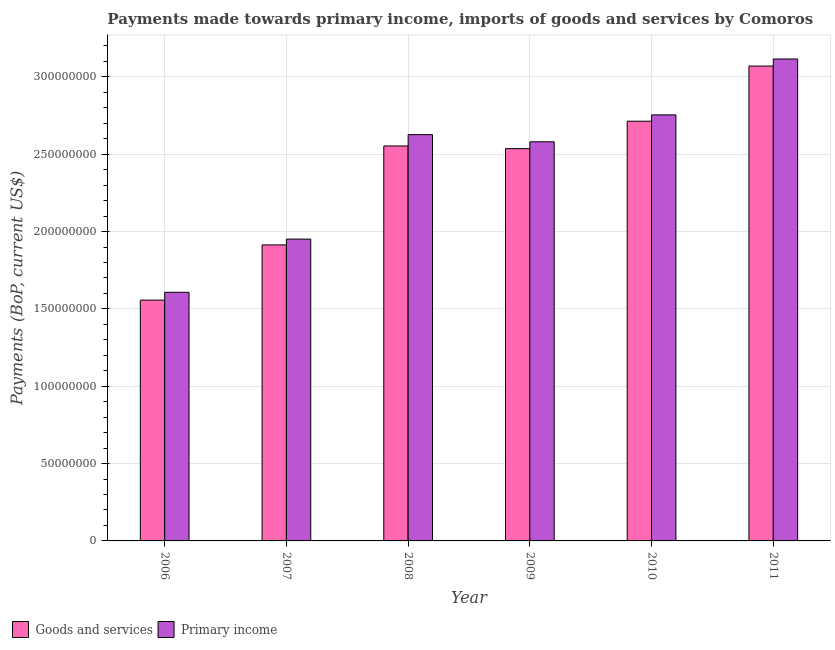How many different coloured bars are there?
Your response must be concise. 2. Are the number of bars per tick equal to the number of legend labels?
Offer a terse response. Yes. How many bars are there on the 5th tick from the left?
Offer a very short reply. 2. What is the payments made towards primary income in 2011?
Your answer should be very brief. 3.12e+08. Across all years, what is the maximum payments made towards goods and services?
Ensure brevity in your answer.  3.07e+08. Across all years, what is the minimum payments made towards goods and services?
Offer a terse response. 1.56e+08. What is the total payments made towards goods and services in the graph?
Offer a very short reply. 1.43e+09. What is the difference between the payments made towards goods and services in 2007 and that in 2010?
Provide a short and direct response. -8.00e+07. What is the difference between the payments made towards primary income in 2009 and the payments made towards goods and services in 2007?
Offer a terse response. 6.29e+07. What is the average payments made towards primary income per year?
Ensure brevity in your answer.  2.44e+08. In the year 2006, what is the difference between the payments made towards goods and services and payments made towards primary income?
Provide a short and direct response. 0. In how many years, is the payments made towards primary income greater than 100000000 US$?
Keep it short and to the point. 6. What is the ratio of the payments made towards goods and services in 2009 to that in 2010?
Give a very brief answer. 0.93. What is the difference between the highest and the second highest payments made towards goods and services?
Provide a short and direct response. 3.57e+07. What is the difference between the highest and the lowest payments made towards primary income?
Keep it short and to the point. 1.51e+08. In how many years, is the payments made towards goods and services greater than the average payments made towards goods and services taken over all years?
Ensure brevity in your answer.  4. What does the 2nd bar from the left in 2007 represents?
Ensure brevity in your answer.  Primary income. What does the 2nd bar from the right in 2011 represents?
Your response must be concise. Goods and services. What is the difference between two consecutive major ticks on the Y-axis?
Ensure brevity in your answer.  5.00e+07. Are the values on the major ticks of Y-axis written in scientific E-notation?
Offer a terse response. No. Does the graph contain any zero values?
Your answer should be very brief. No. Where does the legend appear in the graph?
Offer a very short reply. Bottom left. How are the legend labels stacked?
Provide a succinct answer. Horizontal. What is the title of the graph?
Give a very brief answer. Payments made towards primary income, imports of goods and services by Comoros. What is the label or title of the X-axis?
Offer a terse response. Year. What is the label or title of the Y-axis?
Give a very brief answer. Payments (BoP, current US$). What is the Payments (BoP, current US$) in Goods and services in 2006?
Offer a terse response. 1.56e+08. What is the Payments (BoP, current US$) in Primary income in 2006?
Provide a short and direct response. 1.61e+08. What is the Payments (BoP, current US$) of Goods and services in 2007?
Ensure brevity in your answer.  1.91e+08. What is the Payments (BoP, current US$) of Primary income in 2007?
Your answer should be very brief. 1.95e+08. What is the Payments (BoP, current US$) of Goods and services in 2008?
Ensure brevity in your answer.  2.55e+08. What is the Payments (BoP, current US$) in Primary income in 2008?
Offer a very short reply. 2.63e+08. What is the Payments (BoP, current US$) in Goods and services in 2009?
Offer a very short reply. 2.54e+08. What is the Payments (BoP, current US$) of Primary income in 2009?
Provide a short and direct response. 2.58e+08. What is the Payments (BoP, current US$) in Goods and services in 2010?
Ensure brevity in your answer.  2.71e+08. What is the Payments (BoP, current US$) of Primary income in 2010?
Offer a terse response. 2.75e+08. What is the Payments (BoP, current US$) of Goods and services in 2011?
Make the answer very short. 3.07e+08. What is the Payments (BoP, current US$) in Primary income in 2011?
Provide a short and direct response. 3.12e+08. Across all years, what is the maximum Payments (BoP, current US$) in Goods and services?
Your answer should be very brief. 3.07e+08. Across all years, what is the maximum Payments (BoP, current US$) in Primary income?
Your answer should be very brief. 3.12e+08. Across all years, what is the minimum Payments (BoP, current US$) in Goods and services?
Provide a short and direct response. 1.56e+08. Across all years, what is the minimum Payments (BoP, current US$) of Primary income?
Give a very brief answer. 1.61e+08. What is the total Payments (BoP, current US$) in Goods and services in the graph?
Give a very brief answer. 1.43e+09. What is the total Payments (BoP, current US$) of Primary income in the graph?
Your answer should be compact. 1.46e+09. What is the difference between the Payments (BoP, current US$) of Goods and services in 2006 and that in 2007?
Provide a short and direct response. -3.57e+07. What is the difference between the Payments (BoP, current US$) in Primary income in 2006 and that in 2007?
Make the answer very short. -3.44e+07. What is the difference between the Payments (BoP, current US$) in Goods and services in 2006 and that in 2008?
Offer a very short reply. -9.97e+07. What is the difference between the Payments (BoP, current US$) in Primary income in 2006 and that in 2008?
Ensure brevity in your answer.  -1.02e+08. What is the difference between the Payments (BoP, current US$) in Goods and services in 2006 and that in 2009?
Your response must be concise. -9.79e+07. What is the difference between the Payments (BoP, current US$) of Primary income in 2006 and that in 2009?
Make the answer very short. -9.73e+07. What is the difference between the Payments (BoP, current US$) of Goods and services in 2006 and that in 2010?
Your response must be concise. -1.16e+08. What is the difference between the Payments (BoP, current US$) in Primary income in 2006 and that in 2010?
Ensure brevity in your answer.  -1.15e+08. What is the difference between the Payments (BoP, current US$) of Goods and services in 2006 and that in 2011?
Provide a short and direct response. -1.51e+08. What is the difference between the Payments (BoP, current US$) of Primary income in 2006 and that in 2011?
Ensure brevity in your answer.  -1.51e+08. What is the difference between the Payments (BoP, current US$) in Goods and services in 2007 and that in 2008?
Provide a succinct answer. -6.40e+07. What is the difference between the Payments (BoP, current US$) of Primary income in 2007 and that in 2008?
Provide a short and direct response. -6.75e+07. What is the difference between the Payments (BoP, current US$) of Goods and services in 2007 and that in 2009?
Keep it short and to the point. -6.22e+07. What is the difference between the Payments (BoP, current US$) of Primary income in 2007 and that in 2009?
Ensure brevity in your answer.  -6.29e+07. What is the difference between the Payments (BoP, current US$) of Goods and services in 2007 and that in 2010?
Offer a very short reply. -8.00e+07. What is the difference between the Payments (BoP, current US$) in Primary income in 2007 and that in 2010?
Give a very brief answer. -8.03e+07. What is the difference between the Payments (BoP, current US$) of Goods and services in 2007 and that in 2011?
Provide a succinct answer. -1.16e+08. What is the difference between the Payments (BoP, current US$) of Primary income in 2007 and that in 2011?
Offer a very short reply. -1.16e+08. What is the difference between the Payments (BoP, current US$) in Goods and services in 2008 and that in 2009?
Offer a terse response. 1.74e+06. What is the difference between the Payments (BoP, current US$) in Primary income in 2008 and that in 2009?
Give a very brief answer. 4.63e+06. What is the difference between the Payments (BoP, current US$) in Goods and services in 2008 and that in 2010?
Ensure brevity in your answer.  -1.60e+07. What is the difference between the Payments (BoP, current US$) in Primary income in 2008 and that in 2010?
Offer a terse response. -1.28e+07. What is the difference between the Payments (BoP, current US$) in Goods and services in 2008 and that in 2011?
Your answer should be very brief. -5.17e+07. What is the difference between the Payments (BoP, current US$) of Primary income in 2008 and that in 2011?
Make the answer very short. -4.89e+07. What is the difference between the Payments (BoP, current US$) of Goods and services in 2009 and that in 2010?
Your answer should be compact. -1.77e+07. What is the difference between the Payments (BoP, current US$) in Primary income in 2009 and that in 2010?
Ensure brevity in your answer.  -1.74e+07. What is the difference between the Payments (BoP, current US$) in Goods and services in 2009 and that in 2011?
Your answer should be very brief. -5.34e+07. What is the difference between the Payments (BoP, current US$) in Primary income in 2009 and that in 2011?
Ensure brevity in your answer.  -5.35e+07. What is the difference between the Payments (BoP, current US$) in Goods and services in 2010 and that in 2011?
Provide a short and direct response. -3.57e+07. What is the difference between the Payments (BoP, current US$) in Primary income in 2010 and that in 2011?
Provide a succinct answer. -3.61e+07. What is the difference between the Payments (BoP, current US$) in Goods and services in 2006 and the Payments (BoP, current US$) in Primary income in 2007?
Ensure brevity in your answer.  -3.94e+07. What is the difference between the Payments (BoP, current US$) of Goods and services in 2006 and the Payments (BoP, current US$) of Primary income in 2008?
Your answer should be compact. -1.07e+08. What is the difference between the Payments (BoP, current US$) in Goods and services in 2006 and the Payments (BoP, current US$) in Primary income in 2009?
Provide a succinct answer. -1.02e+08. What is the difference between the Payments (BoP, current US$) in Goods and services in 2006 and the Payments (BoP, current US$) in Primary income in 2010?
Offer a terse response. -1.20e+08. What is the difference between the Payments (BoP, current US$) in Goods and services in 2006 and the Payments (BoP, current US$) in Primary income in 2011?
Make the answer very short. -1.56e+08. What is the difference between the Payments (BoP, current US$) of Goods and services in 2007 and the Payments (BoP, current US$) of Primary income in 2008?
Offer a terse response. -7.13e+07. What is the difference between the Payments (BoP, current US$) in Goods and services in 2007 and the Payments (BoP, current US$) in Primary income in 2009?
Your answer should be very brief. -6.67e+07. What is the difference between the Payments (BoP, current US$) in Goods and services in 2007 and the Payments (BoP, current US$) in Primary income in 2010?
Provide a succinct answer. -8.41e+07. What is the difference between the Payments (BoP, current US$) of Goods and services in 2007 and the Payments (BoP, current US$) of Primary income in 2011?
Your answer should be very brief. -1.20e+08. What is the difference between the Payments (BoP, current US$) of Goods and services in 2008 and the Payments (BoP, current US$) of Primary income in 2009?
Keep it short and to the point. -2.69e+06. What is the difference between the Payments (BoP, current US$) of Goods and services in 2008 and the Payments (BoP, current US$) of Primary income in 2010?
Give a very brief answer. -2.01e+07. What is the difference between the Payments (BoP, current US$) of Goods and services in 2008 and the Payments (BoP, current US$) of Primary income in 2011?
Offer a very short reply. -5.62e+07. What is the difference between the Payments (BoP, current US$) in Goods and services in 2009 and the Payments (BoP, current US$) in Primary income in 2010?
Your response must be concise. -2.18e+07. What is the difference between the Payments (BoP, current US$) of Goods and services in 2009 and the Payments (BoP, current US$) of Primary income in 2011?
Your response must be concise. -5.80e+07. What is the difference between the Payments (BoP, current US$) in Goods and services in 2010 and the Payments (BoP, current US$) in Primary income in 2011?
Keep it short and to the point. -4.02e+07. What is the average Payments (BoP, current US$) of Goods and services per year?
Provide a short and direct response. 2.39e+08. What is the average Payments (BoP, current US$) in Primary income per year?
Make the answer very short. 2.44e+08. In the year 2006, what is the difference between the Payments (BoP, current US$) in Goods and services and Payments (BoP, current US$) in Primary income?
Keep it short and to the point. -5.06e+06. In the year 2007, what is the difference between the Payments (BoP, current US$) in Goods and services and Payments (BoP, current US$) in Primary income?
Keep it short and to the point. -3.77e+06. In the year 2008, what is the difference between the Payments (BoP, current US$) of Goods and services and Payments (BoP, current US$) of Primary income?
Your answer should be compact. -7.33e+06. In the year 2009, what is the difference between the Payments (BoP, current US$) of Goods and services and Payments (BoP, current US$) of Primary income?
Your answer should be compact. -4.43e+06. In the year 2010, what is the difference between the Payments (BoP, current US$) of Goods and services and Payments (BoP, current US$) of Primary income?
Offer a very short reply. -4.08e+06. In the year 2011, what is the difference between the Payments (BoP, current US$) in Goods and services and Payments (BoP, current US$) in Primary income?
Keep it short and to the point. -4.58e+06. What is the ratio of the Payments (BoP, current US$) of Goods and services in 2006 to that in 2007?
Make the answer very short. 0.81. What is the ratio of the Payments (BoP, current US$) of Primary income in 2006 to that in 2007?
Your answer should be compact. 0.82. What is the ratio of the Payments (BoP, current US$) in Goods and services in 2006 to that in 2008?
Give a very brief answer. 0.61. What is the ratio of the Payments (BoP, current US$) in Primary income in 2006 to that in 2008?
Ensure brevity in your answer.  0.61. What is the ratio of the Payments (BoP, current US$) in Goods and services in 2006 to that in 2009?
Provide a short and direct response. 0.61. What is the ratio of the Payments (BoP, current US$) of Primary income in 2006 to that in 2009?
Keep it short and to the point. 0.62. What is the ratio of the Payments (BoP, current US$) in Goods and services in 2006 to that in 2010?
Make the answer very short. 0.57. What is the ratio of the Payments (BoP, current US$) of Primary income in 2006 to that in 2010?
Provide a short and direct response. 0.58. What is the ratio of the Payments (BoP, current US$) of Goods and services in 2006 to that in 2011?
Your answer should be very brief. 0.51. What is the ratio of the Payments (BoP, current US$) in Primary income in 2006 to that in 2011?
Provide a short and direct response. 0.52. What is the ratio of the Payments (BoP, current US$) of Goods and services in 2007 to that in 2008?
Give a very brief answer. 0.75. What is the ratio of the Payments (BoP, current US$) in Primary income in 2007 to that in 2008?
Your answer should be very brief. 0.74. What is the ratio of the Payments (BoP, current US$) in Goods and services in 2007 to that in 2009?
Your answer should be very brief. 0.75. What is the ratio of the Payments (BoP, current US$) of Primary income in 2007 to that in 2009?
Provide a short and direct response. 0.76. What is the ratio of the Payments (BoP, current US$) in Goods and services in 2007 to that in 2010?
Ensure brevity in your answer.  0.71. What is the ratio of the Payments (BoP, current US$) in Primary income in 2007 to that in 2010?
Provide a short and direct response. 0.71. What is the ratio of the Payments (BoP, current US$) of Goods and services in 2007 to that in 2011?
Your response must be concise. 0.62. What is the ratio of the Payments (BoP, current US$) of Primary income in 2007 to that in 2011?
Give a very brief answer. 0.63. What is the ratio of the Payments (BoP, current US$) in Goods and services in 2008 to that in 2009?
Provide a short and direct response. 1.01. What is the ratio of the Payments (BoP, current US$) of Primary income in 2008 to that in 2009?
Ensure brevity in your answer.  1.02. What is the ratio of the Payments (BoP, current US$) of Goods and services in 2008 to that in 2010?
Your answer should be very brief. 0.94. What is the ratio of the Payments (BoP, current US$) in Primary income in 2008 to that in 2010?
Provide a short and direct response. 0.95. What is the ratio of the Payments (BoP, current US$) in Goods and services in 2008 to that in 2011?
Make the answer very short. 0.83. What is the ratio of the Payments (BoP, current US$) of Primary income in 2008 to that in 2011?
Your response must be concise. 0.84. What is the ratio of the Payments (BoP, current US$) of Goods and services in 2009 to that in 2010?
Offer a very short reply. 0.93. What is the ratio of the Payments (BoP, current US$) of Primary income in 2009 to that in 2010?
Make the answer very short. 0.94. What is the ratio of the Payments (BoP, current US$) in Goods and services in 2009 to that in 2011?
Keep it short and to the point. 0.83. What is the ratio of the Payments (BoP, current US$) of Primary income in 2009 to that in 2011?
Provide a short and direct response. 0.83. What is the ratio of the Payments (BoP, current US$) in Goods and services in 2010 to that in 2011?
Offer a terse response. 0.88. What is the ratio of the Payments (BoP, current US$) in Primary income in 2010 to that in 2011?
Provide a short and direct response. 0.88. What is the difference between the highest and the second highest Payments (BoP, current US$) in Goods and services?
Provide a succinct answer. 3.57e+07. What is the difference between the highest and the second highest Payments (BoP, current US$) in Primary income?
Your answer should be compact. 3.61e+07. What is the difference between the highest and the lowest Payments (BoP, current US$) of Goods and services?
Give a very brief answer. 1.51e+08. What is the difference between the highest and the lowest Payments (BoP, current US$) of Primary income?
Your answer should be compact. 1.51e+08. 